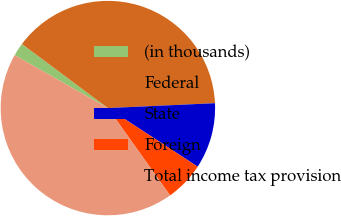Convert chart. <chart><loc_0><loc_0><loc_500><loc_500><pie_chart><fcel>(in thousands)<fcel>Federal<fcel>State<fcel>Foreign<fcel>Total income tax provision<nl><fcel>1.98%<fcel>39.08%<fcel>9.93%<fcel>5.95%<fcel>43.06%<nl></chart> 